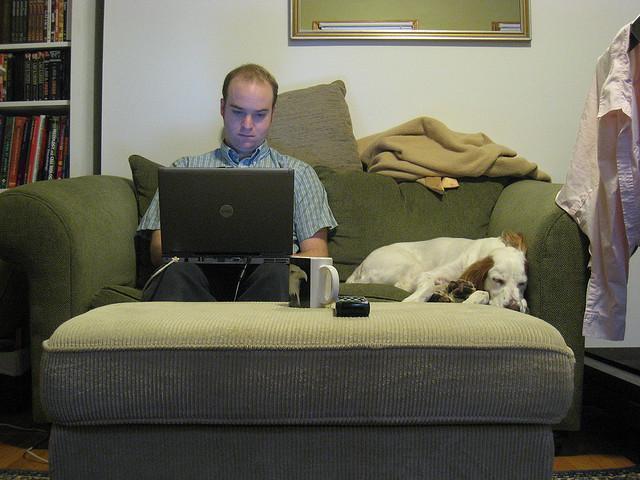What type of potentially harmful light does the laptop screen produce?
Answer the question by selecting the correct answer among the 4 following choices.
Options: Rainbow waves, flashing lights, uv rays, neon lights. Uv rays. 